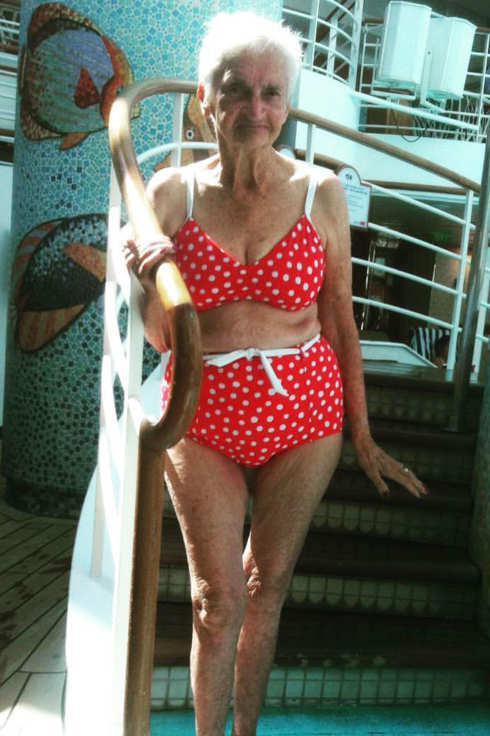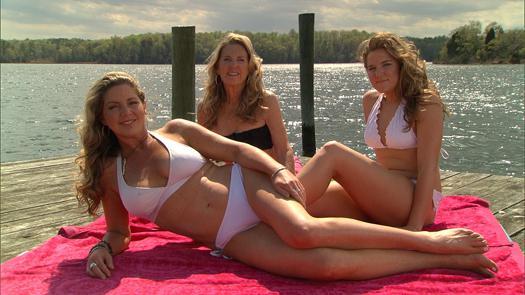The first image is the image on the left, the second image is the image on the right. Analyze the images presented: Is the assertion "An image shows a trio of swimwear models, with at least one wearing a one-piece suit." valid? Answer yes or no. No. The first image is the image on the left, the second image is the image on the right. Evaluate the accuracy of this statement regarding the images: "A woman is wearing a red polka dot swimsuit.". Is it true? Answer yes or no. Yes. 